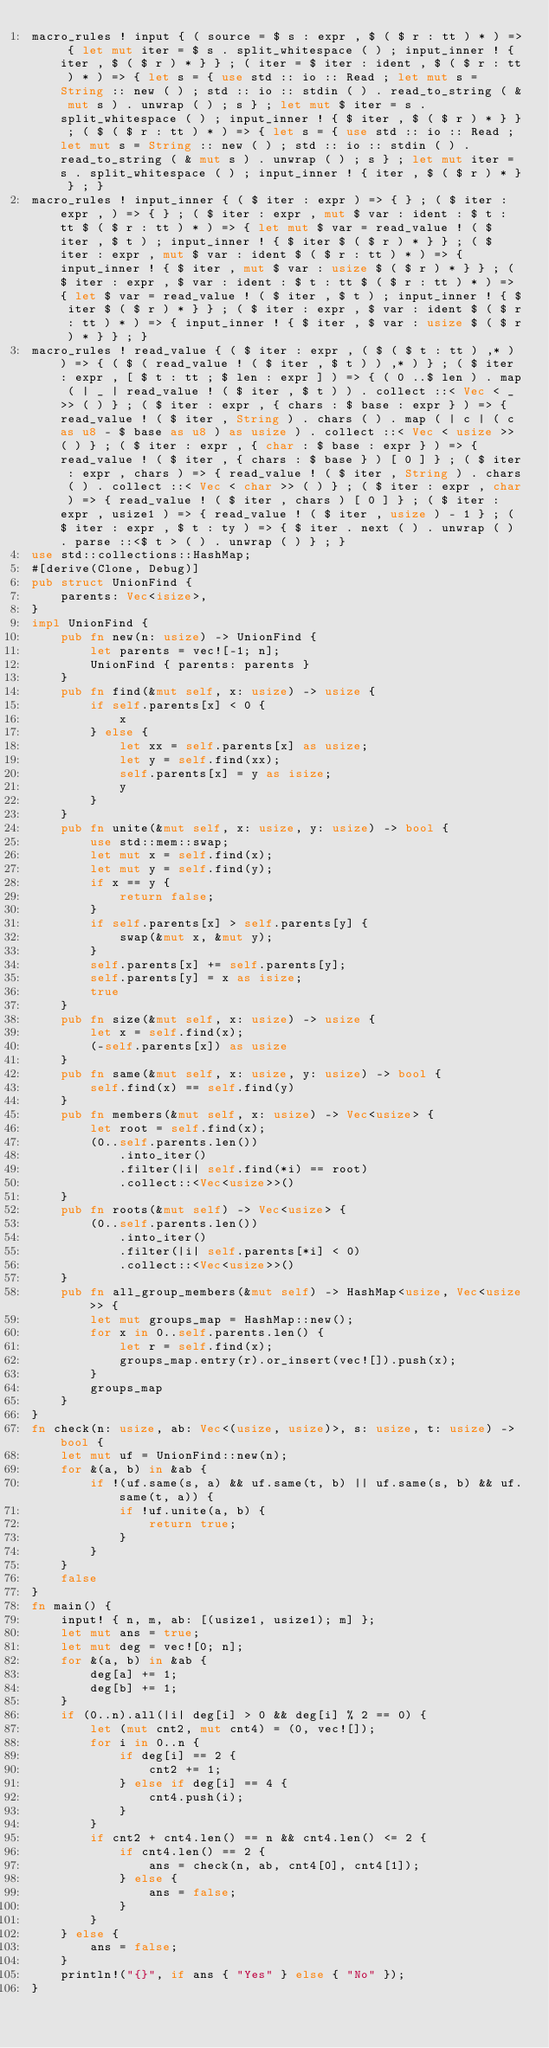Convert code to text. <code><loc_0><loc_0><loc_500><loc_500><_Rust_>macro_rules ! input { ( source = $ s : expr , $ ( $ r : tt ) * ) => { let mut iter = $ s . split_whitespace ( ) ; input_inner ! { iter , $ ( $ r ) * } } ; ( iter = $ iter : ident , $ ( $ r : tt ) * ) => { let s = { use std :: io :: Read ; let mut s = String :: new ( ) ; std :: io :: stdin ( ) . read_to_string ( & mut s ) . unwrap ( ) ; s } ; let mut $ iter = s . split_whitespace ( ) ; input_inner ! { $ iter , $ ( $ r ) * } } ; ( $ ( $ r : tt ) * ) => { let s = { use std :: io :: Read ; let mut s = String :: new ( ) ; std :: io :: stdin ( ) . read_to_string ( & mut s ) . unwrap ( ) ; s } ; let mut iter = s . split_whitespace ( ) ; input_inner ! { iter , $ ( $ r ) * } } ; }
macro_rules ! input_inner { ( $ iter : expr ) => { } ; ( $ iter : expr , ) => { } ; ( $ iter : expr , mut $ var : ident : $ t : tt $ ( $ r : tt ) * ) => { let mut $ var = read_value ! ( $ iter , $ t ) ; input_inner ! { $ iter $ ( $ r ) * } } ; ( $ iter : expr , mut $ var : ident $ ( $ r : tt ) * ) => { input_inner ! { $ iter , mut $ var : usize $ ( $ r ) * } } ; ( $ iter : expr , $ var : ident : $ t : tt $ ( $ r : tt ) * ) => { let $ var = read_value ! ( $ iter , $ t ) ; input_inner ! { $ iter $ ( $ r ) * } } ; ( $ iter : expr , $ var : ident $ ( $ r : tt ) * ) => { input_inner ! { $ iter , $ var : usize $ ( $ r ) * } } ; }
macro_rules ! read_value { ( $ iter : expr , ( $ ( $ t : tt ) ,* ) ) => { ( $ ( read_value ! ( $ iter , $ t ) ) ,* ) } ; ( $ iter : expr , [ $ t : tt ; $ len : expr ] ) => { ( 0 ..$ len ) . map ( | _ | read_value ! ( $ iter , $ t ) ) . collect ::< Vec < _ >> ( ) } ; ( $ iter : expr , { chars : $ base : expr } ) => { read_value ! ( $ iter , String ) . chars ( ) . map ( | c | ( c as u8 - $ base as u8 ) as usize ) . collect ::< Vec < usize >> ( ) } ; ( $ iter : expr , { char : $ base : expr } ) => { read_value ! ( $ iter , { chars : $ base } ) [ 0 ] } ; ( $ iter : expr , chars ) => { read_value ! ( $ iter , String ) . chars ( ) . collect ::< Vec < char >> ( ) } ; ( $ iter : expr , char ) => { read_value ! ( $ iter , chars ) [ 0 ] } ; ( $ iter : expr , usize1 ) => { read_value ! ( $ iter , usize ) - 1 } ; ( $ iter : expr , $ t : ty ) => { $ iter . next ( ) . unwrap ( ) . parse ::<$ t > ( ) . unwrap ( ) } ; }
use std::collections::HashMap;
#[derive(Clone, Debug)]
pub struct UnionFind {
    parents: Vec<isize>,
}
impl UnionFind {
    pub fn new(n: usize) -> UnionFind {
        let parents = vec![-1; n];
        UnionFind { parents: parents }
    }
    pub fn find(&mut self, x: usize) -> usize {
        if self.parents[x] < 0 {
            x
        } else {
            let xx = self.parents[x] as usize;
            let y = self.find(xx);
            self.parents[x] = y as isize;
            y
        }
    }
    pub fn unite(&mut self, x: usize, y: usize) -> bool {
        use std::mem::swap;
        let mut x = self.find(x);
        let mut y = self.find(y);
        if x == y {
            return false;
        }
        if self.parents[x] > self.parents[y] {
            swap(&mut x, &mut y);
        }
        self.parents[x] += self.parents[y];
        self.parents[y] = x as isize;
        true
    }
    pub fn size(&mut self, x: usize) -> usize {
        let x = self.find(x);
        (-self.parents[x]) as usize
    }
    pub fn same(&mut self, x: usize, y: usize) -> bool {
        self.find(x) == self.find(y)
    }
    pub fn members(&mut self, x: usize) -> Vec<usize> {
        let root = self.find(x);
        (0..self.parents.len())
            .into_iter()
            .filter(|i| self.find(*i) == root)
            .collect::<Vec<usize>>()
    }
    pub fn roots(&mut self) -> Vec<usize> {
        (0..self.parents.len())
            .into_iter()
            .filter(|i| self.parents[*i] < 0)
            .collect::<Vec<usize>>()
    }
    pub fn all_group_members(&mut self) -> HashMap<usize, Vec<usize>> {
        let mut groups_map = HashMap::new();
        for x in 0..self.parents.len() {
            let r = self.find(x);
            groups_map.entry(r).or_insert(vec![]).push(x);
        }
        groups_map
    }
}
fn check(n: usize, ab: Vec<(usize, usize)>, s: usize, t: usize) -> bool {
    let mut uf = UnionFind::new(n);
    for &(a, b) in &ab {
        if !(uf.same(s, a) && uf.same(t, b) || uf.same(s, b) && uf.same(t, a)) {
            if !uf.unite(a, b) {
                return true;
            }
        }
    }
    false
}
fn main() {
    input! { n, m, ab: [(usize1, usize1); m] };
    let mut ans = true;
    let mut deg = vec![0; n];
    for &(a, b) in &ab {
        deg[a] += 1;
        deg[b] += 1;
    }
    if (0..n).all(|i| deg[i] > 0 && deg[i] % 2 == 0) {
        let (mut cnt2, mut cnt4) = (0, vec![]);
        for i in 0..n {
            if deg[i] == 2 {
                cnt2 += 1;
            } else if deg[i] == 4 {
                cnt4.push(i);
            }
        }
        if cnt2 + cnt4.len() == n && cnt4.len() <= 2 {
            if cnt4.len() == 2 {
                ans = check(n, ab, cnt4[0], cnt4[1]);
            } else {
                ans = false;
            }
        }
    } else {
        ans = false;
    }
    println!("{}", if ans { "Yes" } else { "No" });
}
</code> 